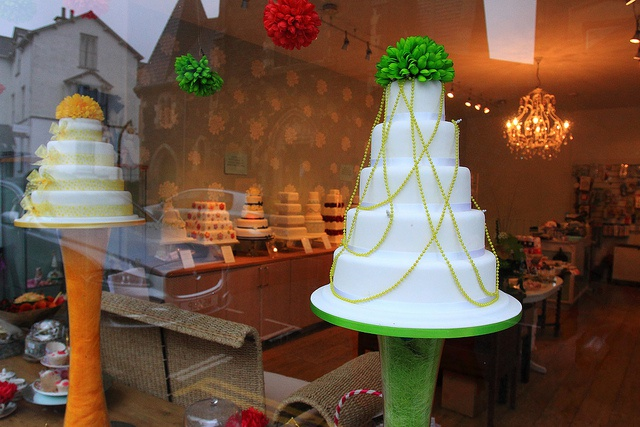Describe the objects in this image and their specific colors. I can see car in lightblue, gray, black, maroon, and darkgray tones, cake in lightblue, lightgray, and darkgray tones, chair in lightblue, maroon, gray, and black tones, dining table in lightblue, darkgreen, and green tones, and cake in lightblue, darkgray, lightgray, and tan tones in this image. 